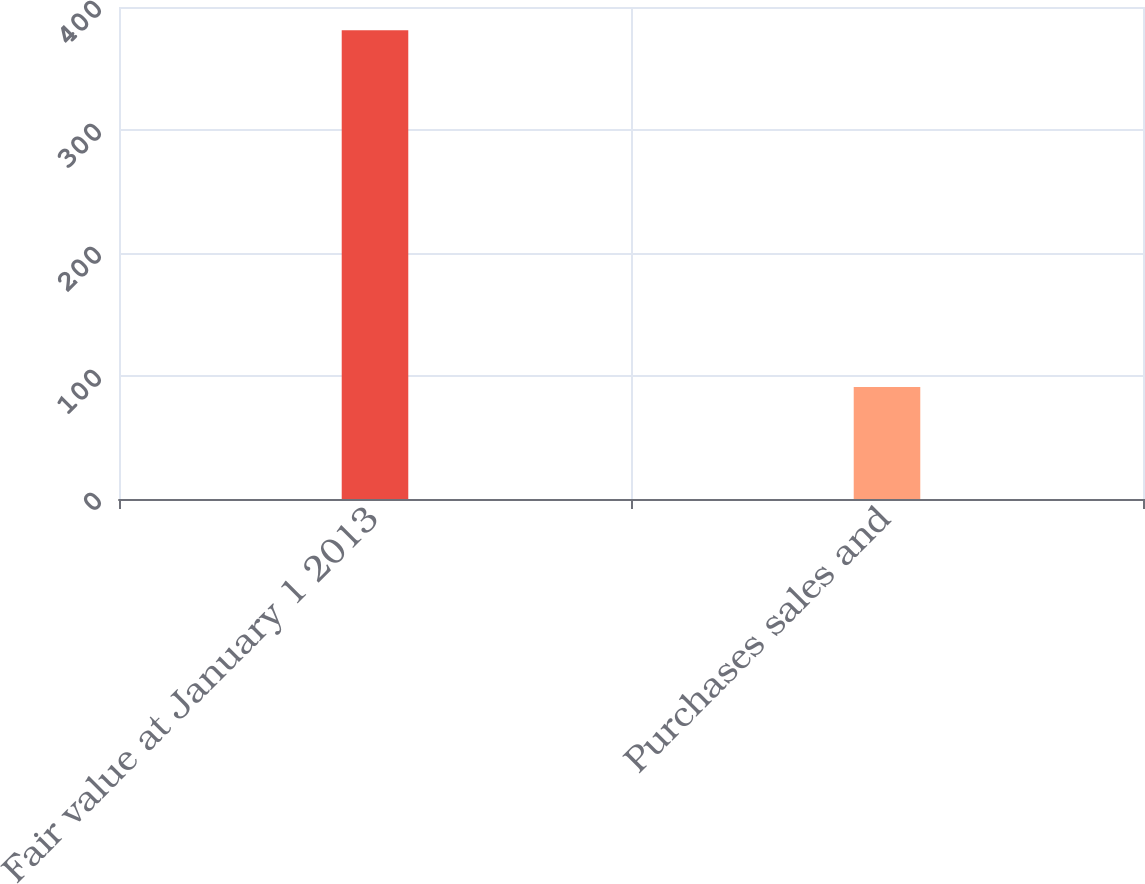Convert chart. <chart><loc_0><loc_0><loc_500><loc_500><bar_chart><fcel>Fair value at January 1 2013<fcel>Purchases sales and<nl><fcel>381<fcel>91<nl></chart> 